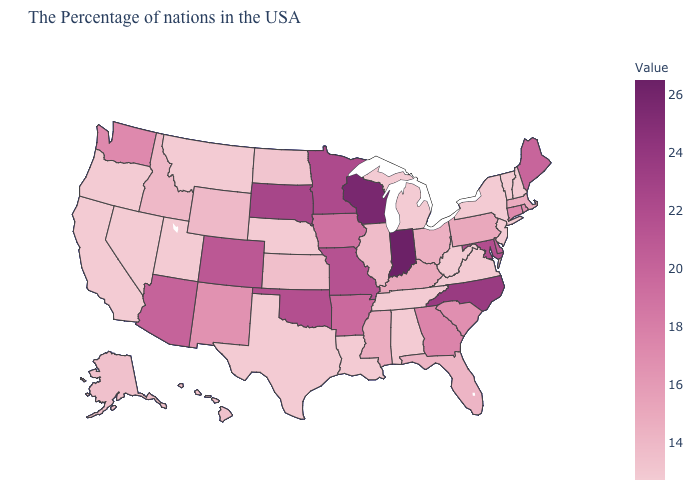Does the map have missing data?
Give a very brief answer. No. Does Texas have a lower value than Florida?
Write a very short answer. Yes. Among the states that border North Dakota , does Minnesota have the highest value?
Be succinct. No. Does the map have missing data?
Quick response, please. No. Does Nevada have the lowest value in the West?
Give a very brief answer. Yes. Does West Virginia have the lowest value in the USA?
Concise answer only. Yes. Which states have the highest value in the USA?
Give a very brief answer. Indiana. 